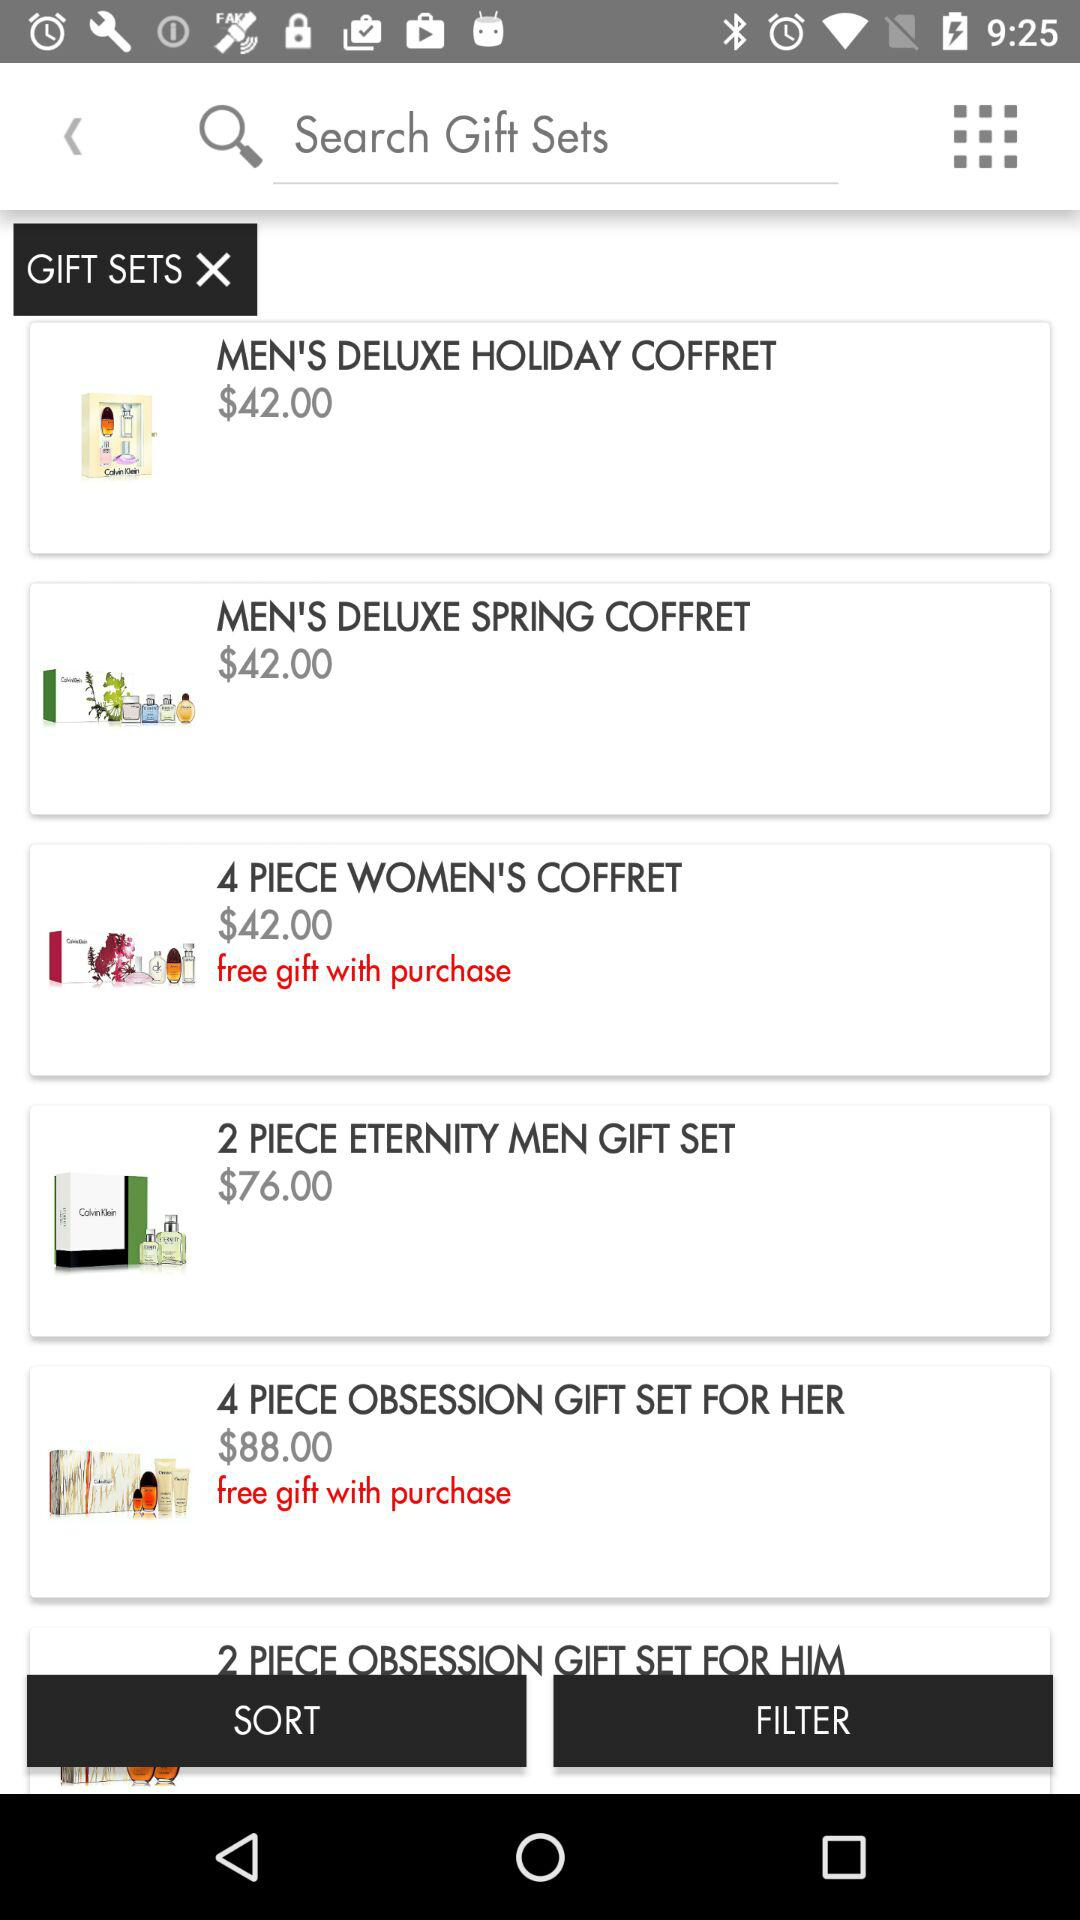Which item has a price of $76? The item is "2 PIECE ETERNITY MEN GIFT SET". 